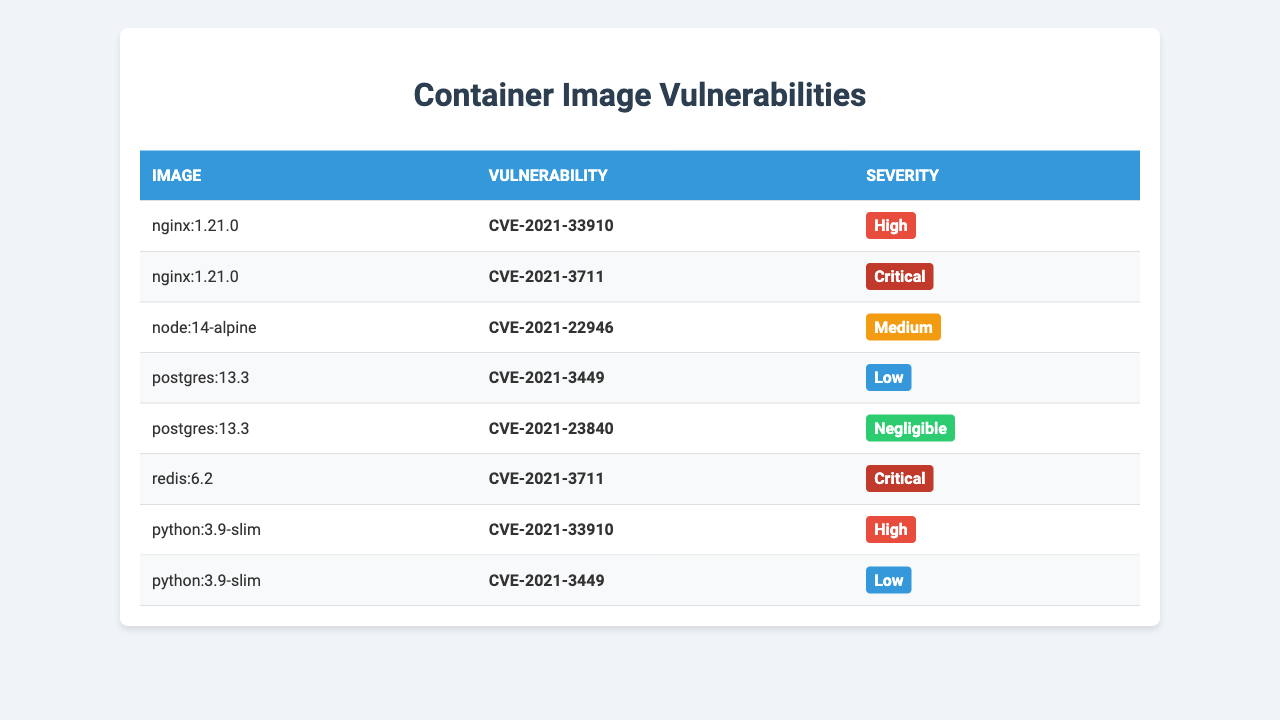What are the images with the highest severity vulnerabilities? By looking at the table, I can see that the images "nginx:1.21.0" and "redis:6.2" both have critical severity vulnerabilities.
Answer: nginx:1.21.0, redis:6.2 How many vulnerabilities does the image "python:3.9-slim" have? Upon checking the row for "python:3.9-slim," I see there are two vulnerabilities listed: CVE-2021-33910 and CVE-2021-3449.
Answer: 2 Is there any image that has a 'Negligible' severity vulnerability? Looking through the table, "postgres:13.3" has a vulnerability (CVE-2021-23840) classified as 'Negligible.'
Answer: Yes What is the total count of 'Critical' vulnerabilities across all images? The table shows that both "nginx:1.21.0" and "redis:6.2" have vulnerabilities marked as 'Critical.' This gives a total count of 2 'Critical' vulnerabilities.
Answer: 2 Which image has the most vulnerabilities listed? By reviewing the entries, "python:3.9-slim" has two listed vulnerabilities (CVE-2021-33910 and CVE-2021-3449), while others have one or two. So it has the most.
Answer: python:3.9-slim Are there any images that have only 'Low' severity vulnerabilities? Checking the table shows that "postgres:13.3" has one 'Low' severity vulnerability (CVE-2021-3449), whereas "python:3.9-slim" has both 'High' and 'Low' ones, so none have only 'Low.'
Answer: No How many images have 'High' severity vulnerabilities? The images "nginx:1.21.0" and "python:3.9-slim" both list vulnerabilities classified as 'High,' indicating a total of 2 images with 'High' severity.
Answer: 2 What is the average severity level of the vulnerabilities detected? The severities can be ranked as: Critical = 4, High = 3, Medium = 2, Low = 1, Negligible = 0. Counting the occurrences and total severity: (3 from 2 'High' + 4 from 2 'Critical' + 2 from 1 'Medium' + 1 from 1 'Low' + 0 from 1 'Negligible') results in 10/7 ≈ 1.43, which would be closest to 'Medium.'
Answer: Medium Which vulnerability appears in more than one image? "CVE-2021-3711" appears in "nginx:1.21.0" and "redis:6.2," indicating it is shared between these two images.
Answer: CVE-2021-3711 How many images are listed overall in the table? By counting the images listed in the first column, there are a total of 5 images: "nginx:1.21.0," "node:14-alpine," "postgres:13.3," "redis:6.2," and "python:3.9-slim."
Answer: 5 